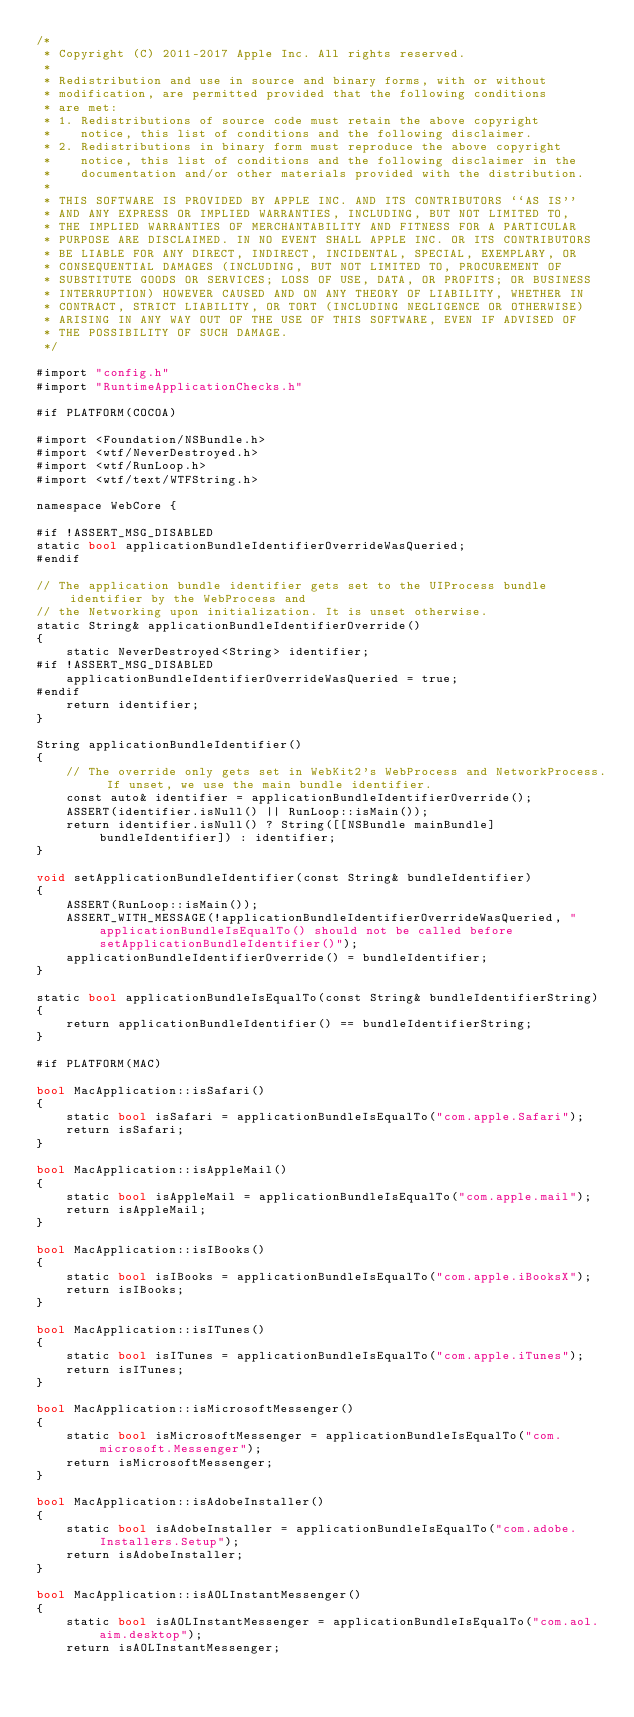Convert code to text. <code><loc_0><loc_0><loc_500><loc_500><_ObjectiveC_>/*
 * Copyright (C) 2011-2017 Apple Inc. All rights reserved.
 *
 * Redistribution and use in source and binary forms, with or without
 * modification, are permitted provided that the following conditions
 * are met:
 * 1. Redistributions of source code must retain the above copyright
 *    notice, this list of conditions and the following disclaimer.
 * 2. Redistributions in binary form must reproduce the above copyright
 *    notice, this list of conditions and the following disclaimer in the
 *    documentation and/or other materials provided with the distribution.
 *
 * THIS SOFTWARE IS PROVIDED BY APPLE INC. AND ITS CONTRIBUTORS ``AS IS''
 * AND ANY EXPRESS OR IMPLIED WARRANTIES, INCLUDING, BUT NOT LIMITED TO,
 * THE IMPLIED WARRANTIES OF MERCHANTABILITY AND FITNESS FOR A PARTICULAR
 * PURPOSE ARE DISCLAIMED. IN NO EVENT SHALL APPLE INC. OR ITS CONTRIBUTORS
 * BE LIABLE FOR ANY DIRECT, INDIRECT, INCIDENTAL, SPECIAL, EXEMPLARY, OR
 * CONSEQUENTIAL DAMAGES (INCLUDING, BUT NOT LIMITED TO, PROCUREMENT OF
 * SUBSTITUTE GOODS OR SERVICES; LOSS OF USE, DATA, OR PROFITS; OR BUSINESS
 * INTERRUPTION) HOWEVER CAUSED AND ON ANY THEORY OF LIABILITY, WHETHER IN
 * CONTRACT, STRICT LIABILITY, OR TORT (INCLUDING NEGLIGENCE OR OTHERWISE)
 * ARISING IN ANY WAY OUT OF THE USE OF THIS SOFTWARE, EVEN IF ADVISED OF
 * THE POSSIBILITY OF SUCH DAMAGE.
 */

#import "config.h"
#import "RuntimeApplicationChecks.h"

#if PLATFORM(COCOA)

#import <Foundation/NSBundle.h>
#import <wtf/NeverDestroyed.h>
#import <wtf/RunLoop.h>
#import <wtf/text/WTFString.h>

namespace WebCore {

#if !ASSERT_MSG_DISABLED
static bool applicationBundleIdentifierOverrideWasQueried;
#endif

// The application bundle identifier gets set to the UIProcess bundle identifier by the WebProcess and
// the Networking upon initialization. It is unset otherwise.
static String& applicationBundleIdentifierOverride()
{
    static NeverDestroyed<String> identifier;
#if !ASSERT_MSG_DISABLED
    applicationBundleIdentifierOverrideWasQueried = true;
#endif
    return identifier;
}

String applicationBundleIdentifier()
{
    // The override only gets set in WebKit2's WebProcess and NetworkProcess. If unset, we use the main bundle identifier.
    const auto& identifier = applicationBundleIdentifierOverride();
    ASSERT(identifier.isNull() || RunLoop::isMain());
    return identifier.isNull() ? String([[NSBundle mainBundle] bundleIdentifier]) : identifier;
}

void setApplicationBundleIdentifier(const String& bundleIdentifier)
{
    ASSERT(RunLoop::isMain());
    ASSERT_WITH_MESSAGE(!applicationBundleIdentifierOverrideWasQueried, "applicationBundleIsEqualTo() should not be called before setApplicationBundleIdentifier()");
    applicationBundleIdentifierOverride() = bundleIdentifier;
}

static bool applicationBundleIsEqualTo(const String& bundleIdentifierString)
{
    return applicationBundleIdentifier() == bundleIdentifierString;
}

#if PLATFORM(MAC)

bool MacApplication::isSafari()
{
    static bool isSafari = applicationBundleIsEqualTo("com.apple.Safari");
    return isSafari;
}

bool MacApplication::isAppleMail()
{
    static bool isAppleMail = applicationBundleIsEqualTo("com.apple.mail");
    return isAppleMail;
}

bool MacApplication::isIBooks()
{
    static bool isIBooks = applicationBundleIsEqualTo("com.apple.iBooksX");
    return isIBooks;
}

bool MacApplication::isITunes()
{
    static bool isITunes = applicationBundleIsEqualTo("com.apple.iTunes");
    return isITunes;
}

bool MacApplication::isMicrosoftMessenger()
{
    static bool isMicrosoftMessenger = applicationBundleIsEqualTo("com.microsoft.Messenger");
    return isMicrosoftMessenger;
}

bool MacApplication::isAdobeInstaller()
{
    static bool isAdobeInstaller = applicationBundleIsEqualTo("com.adobe.Installers.Setup");
    return isAdobeInstaller;
}

bool MacApplication::isAOLInstantMessenger()
{
    static bool isAOLInstantMessenger = applicationBundleIsEqualTo("com.aol.aim.desktop");
    return isAOLInstantMessenger;</code> 